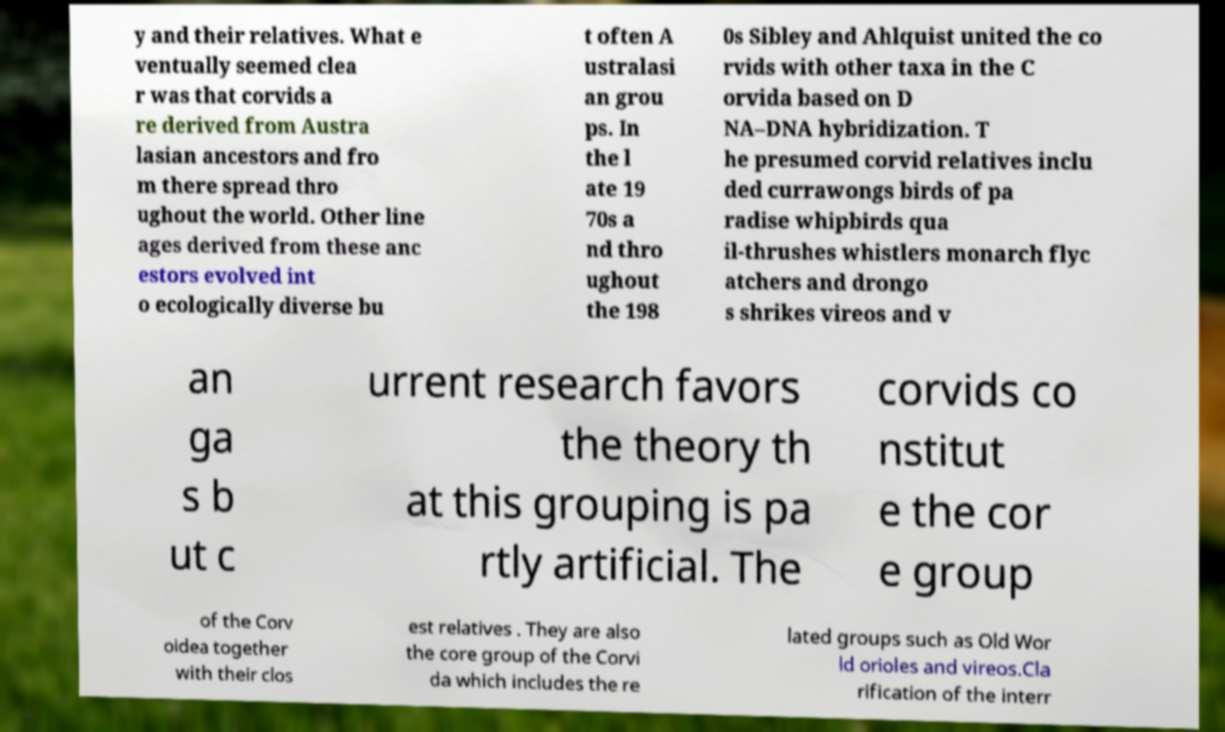Please read and relay the text visible in this image. What does it say? y and their relatives. What e ventually seemed clea r was that corvids a re derived from Austra lasian ancestors and fro m there spread thro ughout the world. Other line ages derived from these anc estors evolved int o ecologically diverse bu t often A ustralasi an grou ps. In the l ate 19 70s a nd thro ughout the 198 0s Sibley and Ahlquist united the co rvids with other taxa in the C orvida based on D NA–DNA hybridization. T he presumed corvid relatives inclu ded currawongs birds of pa radise whipbirds qua il-thrushes whistlers monarch flyc atchers and drongo s shrikes vireos and v an ga s b ut c urrent research favors the theory th at this grouping is pa rtly artificial. The corvids co nstitut e the cor e group of the Corv oidea together with their clos est relatives . They are also the core group of the Corvi da which includes the re lated groups such as Old Wor ld orioles and vireos.Cla rification of the interr 